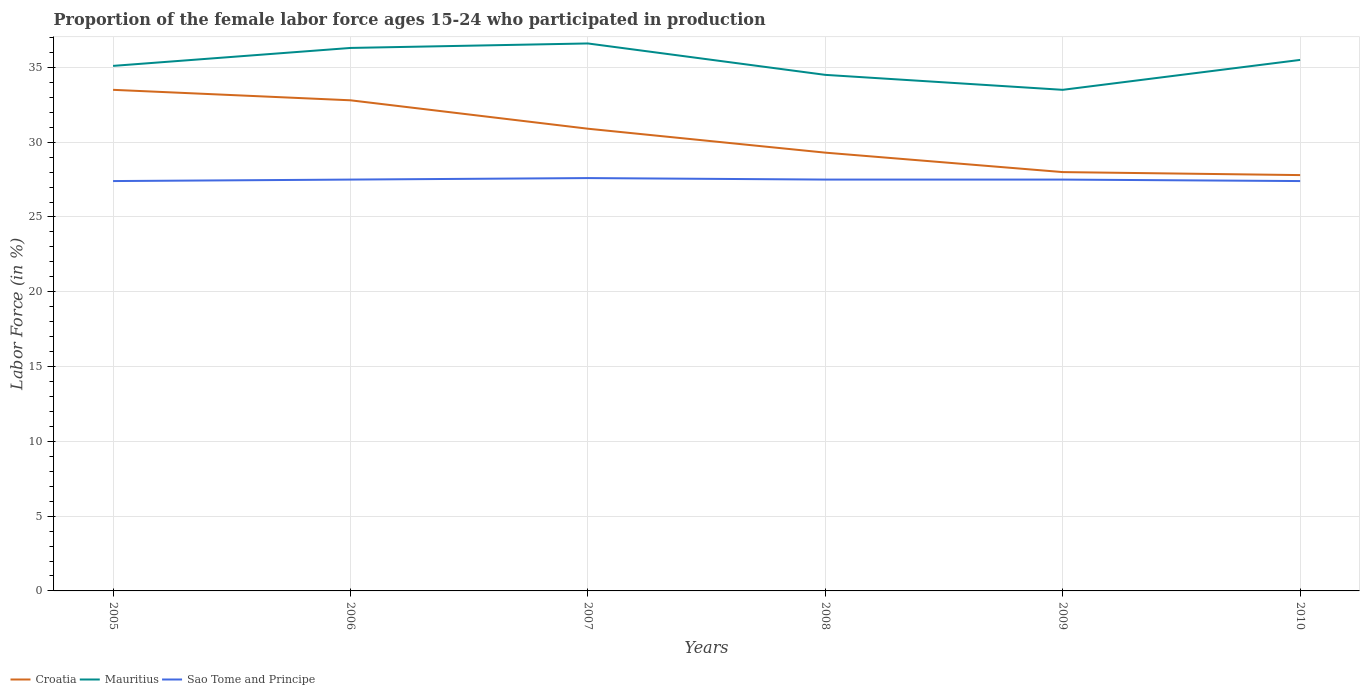Does the line corresponding to Sao Tome and Principe intersect with the line corresponding to Mauritius?
Make the answer very short. No. Is the number of lines equal to the number of legend labels?
Provide a succinct answer. Yes. Across all years, what is the maximum proportion of the female labor force who participated in production in Mauritius?
Make the answer very short. 33.5. In which year was the proportion of the female labor force who participated in production in Sao Tome and Principe maximum?
Your answer should be compact. 2005. What is the total proportion of the female labor force who participated in production in Mauritius in the graph?
Keep it short and to the point. -0.4. What is the difference between the highest and the second highest proportion of the female labor force who participated in production in Croatia?
Offer a terse response. 5.7. What is the difference between the highest and the lowest proportion of the female labor force who participated in production in Croatia?
Offer a very short reply. 3. How many lines are there?
Make the answer very short. 3. What is the difference between two consecutive major ticks on the Y-axis?
Your answer should be very brief. 5. Where does the legend appear in the graph?
Make the answer very short. Bottom left. How many legend labels are there?
Your answer should be compact. 3. How are the legend labels stacked?
Provide a succinct answer. Horizontal. What is the title of the graph?
Make the answer very short. Proportion of the female labor force ages 15-24 who participated in production. Does "Dominica" appear as one of the legend labels in the graph?
Make the answer very short. No. What is the Labor Force (in %) in Croatia in 2005?
Offer a very short reply. 33.5. What is the Labor Force (in %) of Mauritius in 2005?
Your answer should be compact. 35.1. What is the Labor Force (in %) in Sao Tome and Principe in 2005?
Provide a succinct answer. 27.4. What is the Labor Force (in %) of Croatia in 2006?
Provide a short and direct response. 32.8. What is the Labor Force (in %) in Mauritius in 2006?
Provide a succinct answer. 36.3. What is the Labor Force (in %) of Croatia in 2007?
Provide a short and direct response. 30.9. What is the Labor Force (in %) of Mauritius in 2007?
Your answer should be compact. 36.6. What is the Labor Force (in %) in Sao Tome and Principe in 2007?
Ensure brevity in your answer.  27.6. What is the Labor Force (in %) of Croatia in 2008?
Offer a terse response. 29.3. What is the Labor Force (in %) of Mauritius in 2008?
Offer a terse response. 34.5. What is the Labor Force (in %) of Mauritius in 2009?
Offer a very short reply. 33.5. What is the Labor Force (in %) of Croatia in 2010?
Your answer should be very brief. 27.8. What is the Labor Force (in %) of Mauritius in 2010?
Offer a terse response. 35.5. What is the Labor Force (in %) in Sao Tome and Principe in 2010?
Provide a succinct answer. 27.4. Across all years, what is the maximum Labor Force (in %) of Croatia?
Your response must be concise. 33.5. Across all years, what is the maximum Labor Force (in %) in Mauritius?
Provide a succinct answer. 36.6. Across all years, what is the maximum Labor Force (in %) in Sao Tome and Principe?
Provide a succinct answer. 27.6. Across all years, what is the minimum Labor Force (in %) of Croatia?
Ensure brevity in your answer.  27.8. Across all years, what is the minimum Labor Force (in %) of Mauritius?
Your response must be concise. 33.5. Across all years, what is the minimum Labor Force (in %) in Sao Tome and Principe?
Give a very brief answer. 27.4. What is the total Labor Force (in %) in Croatia in the graph?
Give a very brief answer. 182.3. What is the total Labor Force (in %) in Mauritius in the graph?
Your response must be concise. 211.5. What is the total Labor Force (in %) in Sao Tome and Principe in the graph?
Offer a very short reply. 164.9. What is the difference between the Labor Force (in %) of Croatia in 2005 and that in 2006?
Your answer should be compact. 0.7. What is the difference between the Labor Force (in %) of Mauritius in 2005 and that in 2006?
Your response must be concise. -1.2. What is the difference between the Labor Force (in %) of Sao Tome and Principe in 2005 and that in 2006?
Provide a succinct answer. -0.1. What is the difference between the Labor Force (in %) of Croatia in 2005 and that in 2007?
Make the answer very short. 2.6. What is the difference between the Labor Force (in %) of Sao Tome and Principe in 2005 and that in 2007?
Ensure brevity in your answer.  -0.2. What is the difference between the Labor Force (in %) in Mauritius in 2005 and that in 2009?
Give a very brief answer. 1.6. What is the difference between the Labor Force (in %) in Sao Tome and Principe in 2005 and that in 2009?
Your answer should be very brief. -0.1. What is the difference between the Labor Force (in %) of Mauritius in 2005 and that in 2010?
Offer a very short reply. -0.4. What is the difference between the Labor Force (in %) in Sao Tome and Principe in 2005 and that in 2010?
Ensure brevity in your answer.  0. What is the difference between the Labor Force (in %) of Croatia in 2006 and that in 2008?
Your answer should be compact. 3.5. What is the difference between the Labor Force (in %) of Croatia in 2006 and that in 2009?
Your response must be concise. 4.8. What is the difference between the Labor Force (in %) of Sao Tome and Principe in 2006 and that in 2009?
Give a very brief answer. 0. What is the difference between the Labor Force (in %) of Sao Tome and Principe in 2006 and that in 2010?
Provide a short and direct response. 0.1. What is the difference between the Labor Force (in %) in Sao Tome and Principe in 2007 and that in 2008?
Your answer should be very brief. 0.1. What is the difference between the Labor Force (in %) in Croatia in 2007 and that in 2009?
Your answer should be very brief. 2.9. What is the difference between the Labor Force (in %) in Mauritius in 2007 and that in 2009?
Your response must be concise. 3.1. What is the difference between the Labor Force (in %) in Sao Tome and Principe in 2007 and that in 2009?
Provide a succinct answer. 0.1. What is the difference between the Labor Force (in %) of Mauritius in 2007 and that in 2010?
Give a very brief answer. 1.1. What is the difference between the Labor Force (in %) in Sao Tome and Principe in 2007 and that in 2010?
Your response must be concise. 0.2. What is the difference between the Labor Force (in %) in Mauritius in 2008 and that in 2009?
Your response must be concise. 1. What is the difference between the Labor Force (in %) of Sao Tome and Principe in 2008 and that in 2009?
Your response must be concise. 0. What is the difference between the Labor Force (in %) in Croatia in 2008 and that in 2010?
Offer a terse response. 1.5. What is the difference between the Labor Force (in %) in Mauritius in 2008 and that in 2010?
Ensure brevity in your answer.  -1. What is the difference between the Labor Force (in %) in Croatia in 2009 and that in 2010?
Offer a very short reply. 0.2. What is the difference between the Labor Force (in %) in Croatia in 2005 and the Labor Force (in %) in Sao Tome and Principe in 2006?
Your answer should be very brief. 6. What is the difference between the Labor Force (in %) of Mauritius in 2005 and the Labor Force (in %) of Sao Tome and Principe in 2008?
Your answer should be very brief. 7.6. What is the difference between the Labor Force (in %) in Mauritius in 2005 and the Labor Force (in %) in Sao Tome and Principe in 2009?
Keep it short and to the point. 7.6. What is the difference between the Labor Force (in %) of Croatia in 2005 and the Labor Force (in %) of Sao Tome and Principe in 2010?
Provide a succinct answer. 6.1. What is the difference between the Labor Force (in %) in Mauritius in 2005 and the Labor Force (in %) in Sao Tome and Principe in 2010?
Your answer should be very brief. 7.7. What is the difference between the Labor Force (in %) of Croatia in 2006 and the Labor Force (in %) of Mauritius in 2007?
Your response must be concise. -3.8. What is the difference between the Labor Force (in %) of Croatia in 2006 and the Labor Force (in %) of Sao Tome and Principe in 2007?
Your answer should be compact. 5.2. What is the difference between the Labor Force (in %) of Croatia in 2006 and the Labor Force (in %) of Mauritius in 2008?
Provide a succinct answer. -1.7. What is the difference between the Labor Force (in %) of Mauritius in 2006 and the Labor Force (in %) of Sao Tome and Principe in 2008?
Your response must be concise. 8.8. What is the difference between the Labor Force (in %) of Croatia in 2006 and the Labor Force (in %) of Mauritius in 2009?
Give a very brief answer. -0.7. What is the difference between the Labor Force (in %) of Croatia in 2006 and the Labor Force (in %) of Sao Tome and Principe in 2009?
Make the answer very short. 5.3. What is the difference between the Labor Force (in %) of Mauritius in 2006 and the Labor Force (in %) of Sao Tome and Principe in 2009?
Make the answer very short. 8.8. What is the difference between the Labor Force (in %) of Croatia in 2007 and the Labor Force (in %) of Sao Tome and Principe in 2008?
Your answer should be very brief. 3.4. What is the difference between the Labor Force (in %) in Mauritius in 2007 and the Labor Force (in %) in Sao Tome and Principe in 2009?
Offer a very short reply. 9.1. What is the difference between the Labor Force (in %) of Croatia in 2007 and the Labor Force (in %) of Mauritius in 2010?
Your answer should be compact. -4.6. What is the difference between the Labor Force (in %) of Mauritius in 2007 and the Labor Force (in %) of Sao Tome and Principe in 2010?
Make the answer very short. 9.2. What is the difference between the Labor Force (in %) of Mauritius in 2008 and the Labor Force (in %) of Sao Tome and Principe in 2009?
Your answer should be very brief. 7. What is the difference between the Labor Force (in %) of Croatia in 2008 and the Labor Force (in %) of Sao Tome and Principe in 2010?
Provide a short and direct response. 1.9. What is the difference between the Labor Force (in %) of Croatia in 2009 and the Labor Force (in %) of Mauritius in 2010?
Ensure brevity in your answer.  -7.5. What is the difference between the Labor Force (in %) in Mauritius in 2009 and the Labor Force (in %) in Sao Tome and Principe in 2010?
Give a very brief answer. 6.1. What is the average Labor Force (in %) in Croatia per year?
Ensure brevity in your answer.  30.38. What is the average Labor Force (in %) of Mauritius per year?
Provide a short and direct response. 35.25. What is the average Labor Force (in %) of Sao Tome and Principe per year?
Provide a succinct answer. 27.48. In the year 2005, what is the difference between the Labor Force (in %) of Croatia and Labor Force (in %) of Mauritius?
Ensure brevity in your answer.  -1.6. In the year 2005, what is the difference between the Labor Force (in %) of Croatia and Labor Force (in %) of Sao Tome and Principe?
Your answer should be very brief. 6.1. In the year 2005, what is the difference between the Labor Force (in %) in Mauritius and Labor Force (in %) in Sao Tome and Principe?
Offer a terse response. 7.7. In the year 2006, what is the difference between the Labor Force (in %) of Croatia and Labor Force (in %) of Mauritius?
Give a very brief answer. -3.5. In the year 2006, what is the difference between the Labor Force (in %) in Mauritius and Labor Force (in %) in Sao Tome and Principe?
Your response must be concise. 8.8. In the year 2007, what is the difference between the Labor Force (in %) of Croatia and Labor Force (in %) of Mauritius?
Provide a short and direct response. -5.7. In the year 2007, what is the difference between the Labor Force (in %) in Mauritius and Labor Force (in %) in Sao Tome and Principe?
Keep it short and to the point. 9. In the year 2009, what is the difference between the Labor Force (in %) in Croatia and Labor Force (in %) in Sao Tome and Principe?
Give a very brief answer. 0.5. In the year 2010, what is the difference between the Labor Force (in %) of Croatia and Labor Force (in %) of Mauritius?
Make the answer very short. -7.7. In the year 2010, what is the difference between the Labor Force (in %) in Croatia and Labor Force (in %) in Sao Tome and Principe?
Give a very brief answer. 0.4. What is the ratio of the Labor Force (in %) of Croatia in 2005 to that in 2006?
Your answer should be compact. 1.02. What is the ratio of the Labor Force (in %) in Mauritius in 2005 to that in 2006?
Keep it short and to the point. 0.97. What is the ratio of the Labor Force (in %) in Croatia in 2005 to that in 2007?
Offer a terse response. 1.08. What is the ratio of the Labor Force (in %) in Croatia in 2005 to that in 2008?
Offer a terse response. 1.14. What is the ratio of the Labor Force (in %) in Mauritius in 2005 to that in 2008?
Your answer should be very brief. 1.02. What is the ratio of the Labor Force (in %) of Sao Tome and Principe in 2005 to that in 2008?
Your response must be concise. 1. What is the ratio of the Labor Force (in %) of Croatia in 2005 to that in 2009?
Give a very brief answer. 1.2. What is the ratio of the Labor Force (in %) of Mauritius in 2005 to that in 2009?
Keep it short and to the point. 1.05. What is the ratio of the Labor Force (in %) in Croatia in 2005 to that in 2010?
Your answer should be very brief. 1.21. What is the ratio of the Labor Force (in %) in Mauritius in 2005 to that in 2010?
Your response must be concise. 0.99. What is the ratio of the Labor Force (in %) in Sao Tome and Principe in 2005 to that in 2010?
Make the answer very short. 1. What is the ratio of the Labor Force (in %) of Croatia in 2006 to that in 2007?
Ensure brevity in your answer.  1.06. What is the ratio of the Labor Force (in %) of Sao Tome and Principe in 2006 to that in 2007?
Provide a succinct answer. 1. What is the ratio of the Labor Force (in %) of Croatia in 2006 to that in 2008?
Provide a succinct answer. 1.12. What is the ratio of the Labor Force (in %) in Mauritius in 2006 to that in 2008?
Your answer should be compact. 1.05. What is the ratio of the Labor Force (in %) of Croatia in 2006 to that in 2009?
Your response must be concise. 1.17. What is the ratio of the Labor Force (in %) in Mauritius in 2006 to that in 2009?
Your response must be concise. 1.08. What is the ratio of the Labor Force (in %) in Croatia in 2006 to that in 2010?
Give a very brief answer. 1.18. What is the ratio of the Labor Force (in %) in Mauritius in 2006 to that in 2010?
Your response must be concise. 1.02. What is the ratio of the Labor Force (in %) of Croatia in 2007 to that in 2008?
Keep it short and to the point. 1.05. What is the ratio of the Labor Force (in %) in Mauritius in 2007 to that in 2008?
Keep it short and to the point. 1.06. What is the ratio of the Labor Force (in %) of Croatia in 2007 to that in 2009?
Make the answer very short. 1.1. What is the ratio of the Labor Force (in %) of Mauritius in 2007 to that in 2009?
Your response must be concise. 1.09. What is the ratio of the Labor Force (in %) of Croatia in 2007 to that in 2010?
Make the answer very short. 1.11. What is the ratio of the Labor Force (in %) of Mauritius in 2007 to that in 2010?
Your answer should be compact. 1.03. What is the ratio of the Labor Force (in %) of Sao Tome and Principe in 2007 to that in 2010?
Your answer should be very brief. 1.01. What is the ratio of the Labor Force (in %) of Croatia in 2008 to that in 2009?
Offer a very short reply. 1.05. What is the ratio of the Labor Force (in %) in Mauritius in 2008 to that in 2009?
Your response must be concise. 1.03. What is the ratio of the Labor Force (in %) in Croatia in 2008 to that in 2010?
Give a very brief answer. 1.05. What is the ratio of the Labor Force (in %) of Mauritius in 2008 to that in 2010?
Keep it short and to the point. 0.97. What is the ratio of the Labor Force (in %) in Croatia in 2009 to that in 2010?
Keep it short and to the point. 1.01. What is the ratio of the Labor Force (in %) in Mauritius in 2009 to that in 2010?
Provide a short and direct response. 0.94. What is the ratio of the Labor Force (in %) in Sao Tome and Principe in 2009 to that in 2010?
Offer a very short reply. 1. What is the difference between the highest and the second highest Labor Force (in %) of Mauritius?
Provide a short and direct response. 0.3. What is the difference between the highest and the second highest Labor Force (in %) of Sao Tome and Principe?
Your answer should be very brief. 0.1. 